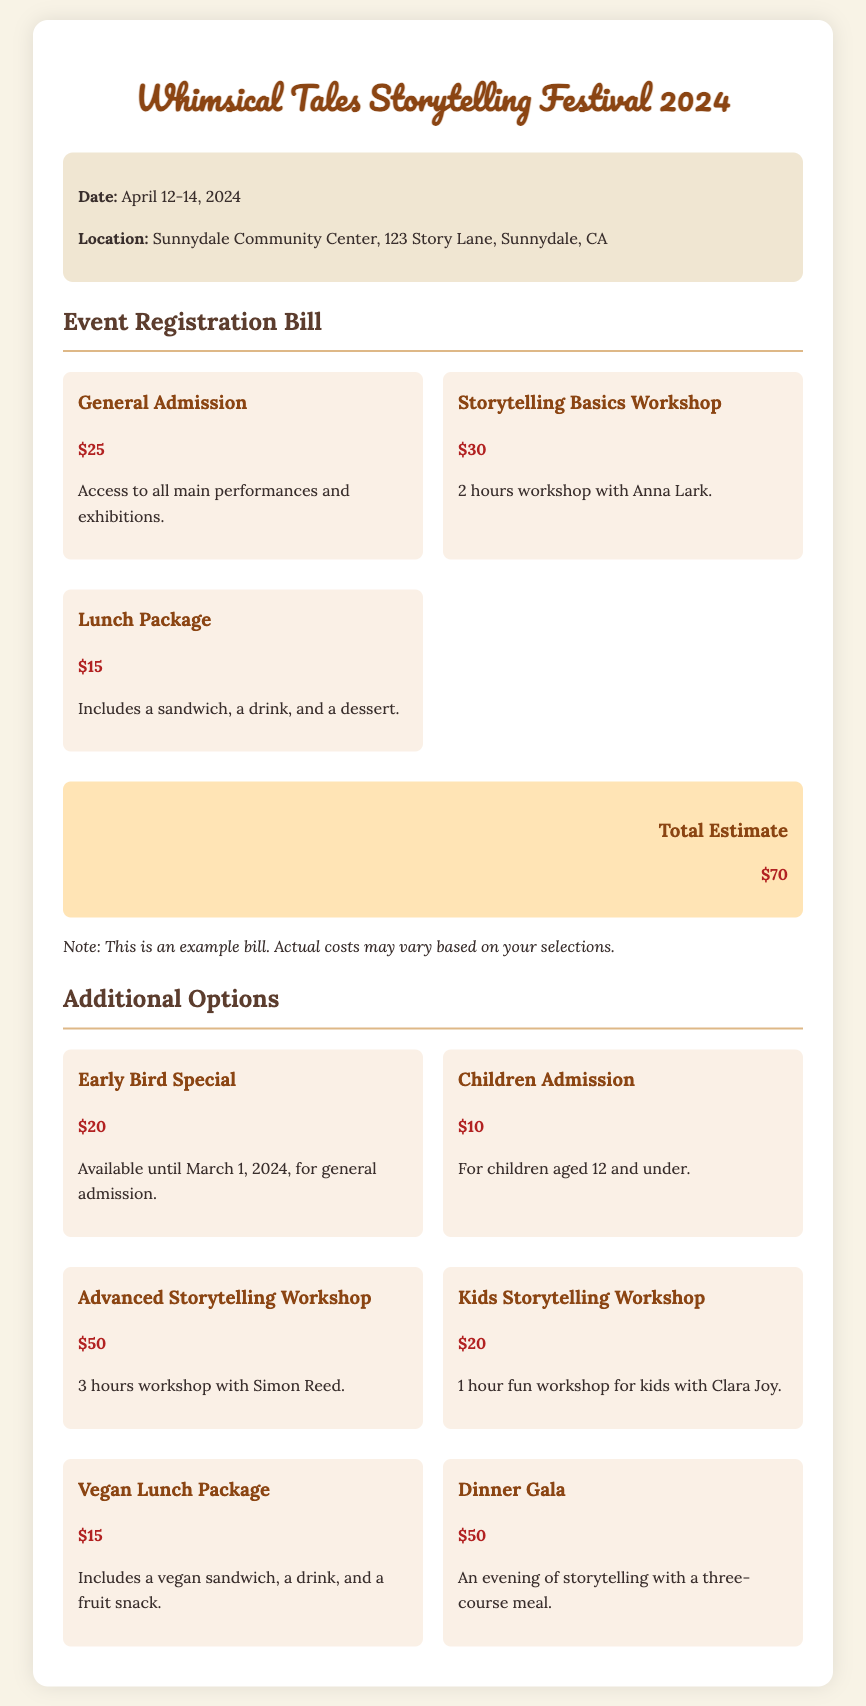what are the festival dates? The festival takes place from April 12 to April 14, 2024.
Answer: April 12-14, 2024 where is the event located? The location of the festival is Sunnydale Community Center, 123 Story Lane, Sunnydale, CA.
Answer: Sunnydale Community Center, 123 Story Lane, Sunnydale, CA how much is general admission? The cost for general admission is stated as $25.
Answer: $25 what is the price of the Advanced Storytelling Workshop? The document lists the price of the Advanced Storytelling Workshop as $50.
Answer: $50 how much does a Lunch Package cost? The Lunch Package is priced at $15.
Answer: $15 what is included in the dinner gala? The dinner gala includes an evening of storytelling with a three-course meal.
Answer: Three-course meal how much can you save with the Early Bird Special? The Early Bird Special offers savings of $5 off the general admission price of $25.
Answer: $5 what is the total estimated cost for admission, a workshop, and a meal? The total estimated cost is calculated as $25 (admission) + $30 (workshop) + $15 (meal) = $70.
Answer: $70 how much is the Kids Storytelling Workshop? The price for the Kids Storytelling Workshop is $20.
Answer: $20 